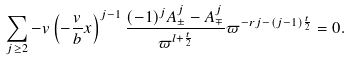Convert formula to latex. <formula><loc_0><loc_0><loc_500><loc_500>\sum _ { j \geq 2 } - v \left ( - \frac { v } { b } x \right ) ^ { j - 1 } \frac { ( - 1 ) ^ { j } A _ { \pm } ^ { j } - A _ { \mp } ^ { j } } { \varpi ^ { l + \frac { t } { 2 } } } \varpi ^ { - r j - ( j - 1 ) \frac { t } { 2 } } = 0 .</formula> 